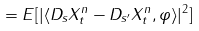<formula> <loc_0><loc_0><loc_500><loc_500>= E [ | \langle D _ { s } X _ { t } ^ { n } - D _ { s ^ { \prime } } X _ { t } ^ { n } , \varphi \rangle | ^ { 2 } ]</formula> 